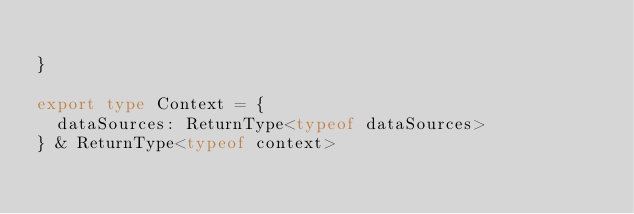<code> <loc_0><loc_0><loc_500><loc_500><_TypeScript_>
}

export type Context = {
	dataSources: ReturnType<typeof dataSources>
} & ReturnType<typeof context>

</code> 